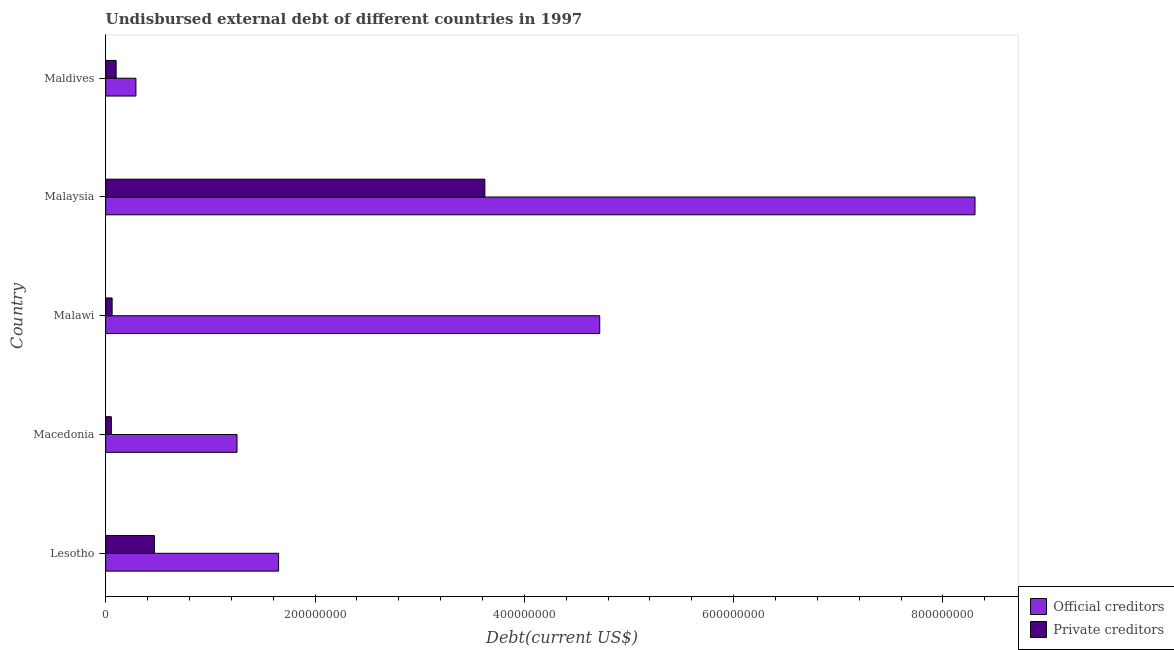How many different coloured bars are there?
Your answer should be compact. 2. How many groups of bars are there?
Offer a terse response. 5. Are the number of bars per tick equal to the number of legend labels?
Your answer should be very brief. Yes. Are the number of bars on each tick of the Y-axis equal?
Give a very brief answer. Yes. How many bars are there on the 3rd tick from the bottom?
Your answer should be very brief. 2. What is the label of the 1st group of bars from the top?
Give a very brief answer. Maldives. What is the undisbursed external debt of private creditors in Macedonia?
Your answer should be compact. 5.40e+06. Across all countries, what is the maximum undisbursed external debt of official creditors?
Provide a short and direct response. 8.31e+08. Across all countries, what is the minimum undisbursed external debt of private creditors?
Give a very brief answer. 5.40e+06. In which country was the undisbursed external debt of official creditors maximum?
Provide a succinct answer. Malaysia. In which country was the undisbursed external debt of private creditors minimum?
Offer a very short reply. Macedonia. What is the total undisbursed external debt of private creditors in the graph?
Keep it short and to the point. 4.30e+08. What is the difference between the undisbursed external debt of private creditors in Lesotho and that in Macedonia?
Your response must be concise. 4.11e+07. What is the difference between the undisbursed external debt of private creditors in Malaysia and the undisbursed external debt of official creditors in Maldives?
Offer a terse response. 3.33e+08. What is the average undisbursed external debt of official creditors per country?
Offer a very short reply. 3.24e+08. What is the difference between the undisbursed external debt of official creditors and undisbursed external debt of private creditors in Lesotho?
Keep it short and to the point. 1.19e+08. What is the ratio of the undisbursed external debt of official creditors in Malawi to that in Malaysia?
Offer a terse response. 0.57. What is the difference between the highest and the second highest undisbursed external debt of private creditors?
Offer a very short reply. 3.16e+08. What is the difference between the highest and the lowest undisbursed external debt of official creditors?
Offer a terse response. 8.02e+08. In how many countries, is the undisbursed external debt of official creditors greater than the average undisbursed external debt of official creditors taken over all countries?
Keep it short and to the point. 2. What does the 1st bar from the top in Malaysia represents?
Keep it short and to the point. Private creditors. What does the 2nd bar from the bottom in Lesotho represents?
Your answer should be compact. Private creditors. Are all the bars in the graph horizontal?
Offer a terse response. Yes. What is the difference between two consecutive major ticks on the X-axis?
Keep it short and to the point. 2.00e+08. Are the values on the major ticks of X-axis written in scientific E-notation?
Make the answer very short. No. Does the graph contain any zero values?
Offer a very short reply. No. What is the title of the graph?
Offer a very short reply. Undisbursed external debt of different countries in 1997. What is the label or title of the X-axis?
Your answer should be compact. Debt(current US$). What is the Debt(current US$) in Official creditors in Lesotho?
Your response must be concise. 1.65e+08. What is the Debt(current US$) in Private creditors in Lesotho?
Your answer should be very brief. 4.65e+07. What is the Debt(current US$) in Official creditors in Macedonia?
Provide a short and direct response. 1.25e+08. What is the Debt(current US$) in Private creditors in Macedonia?
Make the answer very short. 5.40e+06. What is the Debt(current US$) in Official creditors in Malawi?
Your response must be concise. 4.72e+08. What is the Debt(current US$) in Private creditors in Malawi?
Your answer should be compact. 6.14e+06. What is the Debt(current US$) of Official creditors in Malaysia?
Provide a succinct answer. 8.31e+08. What is the Debt(current US$) in Private creditors in Malaysia?
Your answer should be compact. 3.62e+08. What is the Debt(current US$) in Official creditors in Maldives?
Your response must be concise. 2.89e+07. What is the Debt(current US$) of Private creditors in Maldives?
Ensure brevity in your answer.  9.98e+06. Across all countries, what is the maximum Debt(current US$) in Official creditors?
Offer a terse response. 8.31e+08. Across all countries, what is the maximum Debt(current US$) of Private creditors?
Your answer should be compact. 3.62e+08. Across all countries, what is the minimum Debt(current US$) in Official creditors?
Make the answer very short. 2.89e+07. Across all countries, what is the minimum Debt(current US$) of Private creditors?
Give a very brief answer. 5.40e+06. What is the total Debt(current US$) in Official creditors in the graph?
Ensure brevity in your answer.  1.62e+09. What is the total Debt(current US$) of Private creditors in the graph?
Make the answer very short. 4.30e+08. What is the difference between the Debt(current US$) of Official creditors in Lesotho and that in Macedonia?
Give a very brief answer. 3.97e+07. What is the difference between the Debt(current US$) in Private creditors in Lesotho and that in Macedonia?
Make the answer very short. 4.11e+07. What is the difference between the Debt(current US$) in Official creditors in Lesotho and that in Malawi?
Offer a terse response. -3.07e+08. What is the difference between the Debt(current US$) of Private creditors in Lesotho and that in Malawi?
Offer a very short reply. 4.04e+07. What is the difference between the Debt(current US$) of Official creditors in Lesotho and that in Malaysia?
Offer a very short reply. -6.65e+08. What is the difference between the Debt(current US$) of Private creditors in Lesotho and that in Malaysia?
Offer a terse response. -3.16e+08. What is the difference between the Debt(current US$) of Official creditors in Lesotho and that in Maldives?
Your answer should be compact. 1.36e+08. What is the difference between the Debt(current US$) of Private creditors in Lesotho and that in Maldives?
Ensure brevity in your answer.  3.65e+07. What is the difference between the Debt(current US$) in Official creditors in Macedonia and that in Malawi?
Your response must be concise. -3.47e+08. What is the difference between the Debt(current US$) in Private creditors in Macedonia and that in Malawi?
Offer a terse response. -7.37e+05. What is the difference between the Debt(current US$) in Official creditors in Macedonia and that in Malaysia?
Provide a succinct answer. -7.05e+08. What is the difference between the Debt(current US$) in Private creditors in Macedonia and that in Malaysia?
Your answer should be very brief. -3.57e+08. What is the difference between the Debt(current US$) of Official creditors in Macedonia and that in Maldives?
Offer a very short reply. 9.66e+07. What is the difference between the Debt(current US$) in Private creditors in Macedonia and that in Maldives?
Your response must be concise. -4.58e+06. What is the difference between the Debt(current US$) in Official creditors in Malawi and that in Malaysia?
Your answer should be compact. -3.59e+08. What is the difference between the Debt(current US$) of Private creditors in Malawi and that in Malaysia?
Ensure brevity in your answer.  -3.56e+08. What is the difference between the Debt(current US$) in Official creditors in Malawi and that in Maldives?
Provide a succinct answer. 4.43e+08. What is the difference between the Debt(current US$) of Private creditors in Malawi and that in Maldives?
Ensure brevity in your answer.  -3.84e+06. What is the difference between the Debt(current US$) in Official creditors in Malaysia and that in Maldives?
Your answer should be very brief. 8.02e+08. What is the difference between the Debt(current US$) in Private creditors in Malaysia and that in Maldives?
Ensure brevity in your answer.  3.52e+08. What is the difference between the Debt(current US$) of Official creditors in Lesotho and the Debt(current US$) of Private creditors in Macedonia?
Ensure brevity in your answer.  1.60e+08. What is the difference between the Debt(current US$) of Official creditors in Lesotho and the Debt(current US$) of Private creditors in Malawi?
Your response must be concise. 1.59e+08. What is the difference between the Debt(current US$) in Official creditors in Lesotho and the Debt(current US$) in Private creditors in Malaysia?
Your answer should be compact. -1.97e+08. What is the difference between the Debt(current US$) in Official creditors in Lesotho and the Debt(current US$) in Private creditors in Maldives?
Provide a succinct answer. 1.55e+08. What is the difference between the Debt(current US$) in Official creditors in Macedonia and the Debt(current US$) in Private creditors in Malawi?
Provide a short and direct response. 1.19e+08. What is the difference between the Debt(current US$) of Official creditors in Macedonia and the Debt(current US$) of Private creditors in Malaysia?
Offer a terse response. -2.37e+08. What is the difference between the Debt(current US$) of Official creditors in Macedonia and the Debt(current US$) of Private creditors in Maldives?
Make the answer very short. 1.16e+08. What is the difference between the Debt(current US$) of Official creditors in Malawi and the Debt(current US$) of Private creditors in Malaysia?
Offer a terse response. 1.10e+08. What is the difference between the Debt(current US$) of Official creditors in Malawi and the Debt(current US$) of Private creditors in Maldives?
Provide a succinct answer. 4.62e+08. What is the difference between the Debt(current US$) in Official creditors in Malaysia and the Debt(current US$) in Private creditors in Maldives?
Offer a terse response. 8.21e+08. What is the average Debt(current US$) of Official creditors per country?
Keep it short and to the point. 3.24e+08. What is the average Debt(current US$) in Private creditors per country?
Your answer should be very brief. 8.61e+07. What is the difference between the Debt(current US$) in Official creditors and Debt(current US$) in Private creditors in Lesotho?
Offer a terse response. 1.19e+08. What is the difference between the Debt(current US$) of Official creditors and Debt(current US$) of Private creditors in Macedonia?
Offer a terse response. 1.20e+08. What is the difference between the Debt(current US$) of Official creditors and Debt(current US$) of Private creditors in Malawi?
Your answer should be compact. 4.66e+08. What is the difference between the Debt(current US$) of Official creditors and Debt(current US$) of Private creditors in Malaysia?
Offer a very short reply. 4.68e+08. What is the difference between the Debt(current US$) of Official creditors and Debt(current US$) of Private creditors in Maldives?
Keep it short and to the point. 1.89e+07. What is the ratio of the Debt(current US$) in Official creditors in Lesotho to that in Macedonia?
Keep it short and to the point. 1.32. What is the ratio of the Debt(current US$) in Private creditors in Lesotho to that in Macedonia?
Give a very brief answer. 8.61. What is the ratio of the Debt(current US$) in Private creditors in Lesotho to that in Malawi?
Make the answer very short. 7.58. What is the ratio of the Debt(current US$) in Official creditors in Lesotho to that in Malaysia?
Offer a terse response. 0.2. What is the ratio of the Debt(current US$) in Private creditors in Lesotho to that in Malaysia?
Your answer should be very brief. 0.13. What is the ratio of the Debt(current US$) in Official creditors in Lesotho to that in Maldives?
Provide a short and direct response. 5.72. What is the ratio of the Debt(current US$) in Private creditors in Lesotho to that in Maldives?
Give a very brief answer. 4.66. What is the ratio of the Debt(current US$) of Official creditors in Macedonia to that in Malawi?
Your answer should be compact. 0.27. What is the ratio of the Debt(current US$) in Private creditors in Macedonia to that in Malawi?
Offer a very short reply. 0.88. What is the ratio of the Debt(current US$) in Official creditors in Macedonia to that in Malaysia?
Make the answer very short. 0.15. What is the ratio of the Debt(current US$) of Private creditors in Macedonia to that in Malaysia?
Give a very brief answer. 0.01. What is the ratio of the Debt(current US$) of Official creditors in Macedonia to that in Maldives?
Your response must be concise. 4.35. What is the ratio of the Debt(current US$) of Private creditors in Macedonia to that in Maldives?
Provide a succinct answer. 0.54. What is the ratio of the Debt(current US$) in Official creditors in Malawi to that in Malaysia?
Your answer should be compact. 0.57. What is the ratio of the Debt(current US$) in Private creditors in Malawi to that in Malaysia?
Offer a very short reply. 0.02. What is the ratio of the Debt(current US$) in Official creditors in Malawi to that in Maldives?
Offer a very short reply. 16.35. What is the ratio of the Debt(current US$) in Private creditors in Malawi to that in Maldives?
Make the answer very short. 0.62. What is the ratio of the Debt(current US$) of Official creditors in Malaysia to that in Maldives?
Keep it short and to the point. 28.76. What is the ratio of the Debt(current US$) of Private creditors in Malaysia to that in Maldives?
Ensure brevity in your answer.  36.3. What is the difference between the highest and the second highest Debt(current US$) in Official creditors?
Offer a terse response. 3.59e+08. What is the difference between the highest and the second highest Debt(current US$) of Private creditors?
Keep it short and to the point. 3.16e+08. What is the difference between the highest and the lowest Debt(current US$) in Official creditors?
Provide a short and direct response. 8.02e+08. What is the difference between the highest and the lowest Debt(current US$) of Private creditors?
Your answer should be compact. 3.57e+08. 